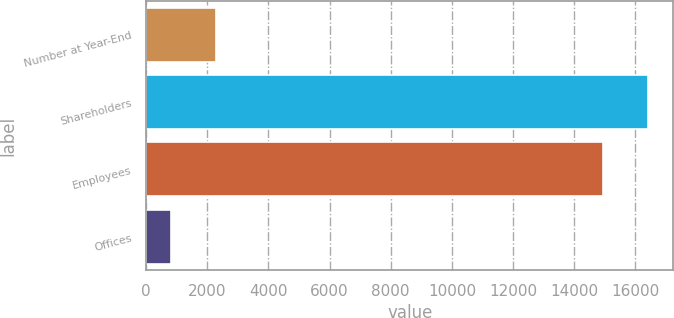Convert chart. <chart><loc_0><loc_0><loc_500><loc_500><bar_chart><fcel>Number at Year-End<fcel>Shareholders<fcel>Employees<fcel>Offices<nl><fcel>2281.4<fcel>16425.4<fcel>14943<fcel>799<nl></chart> 